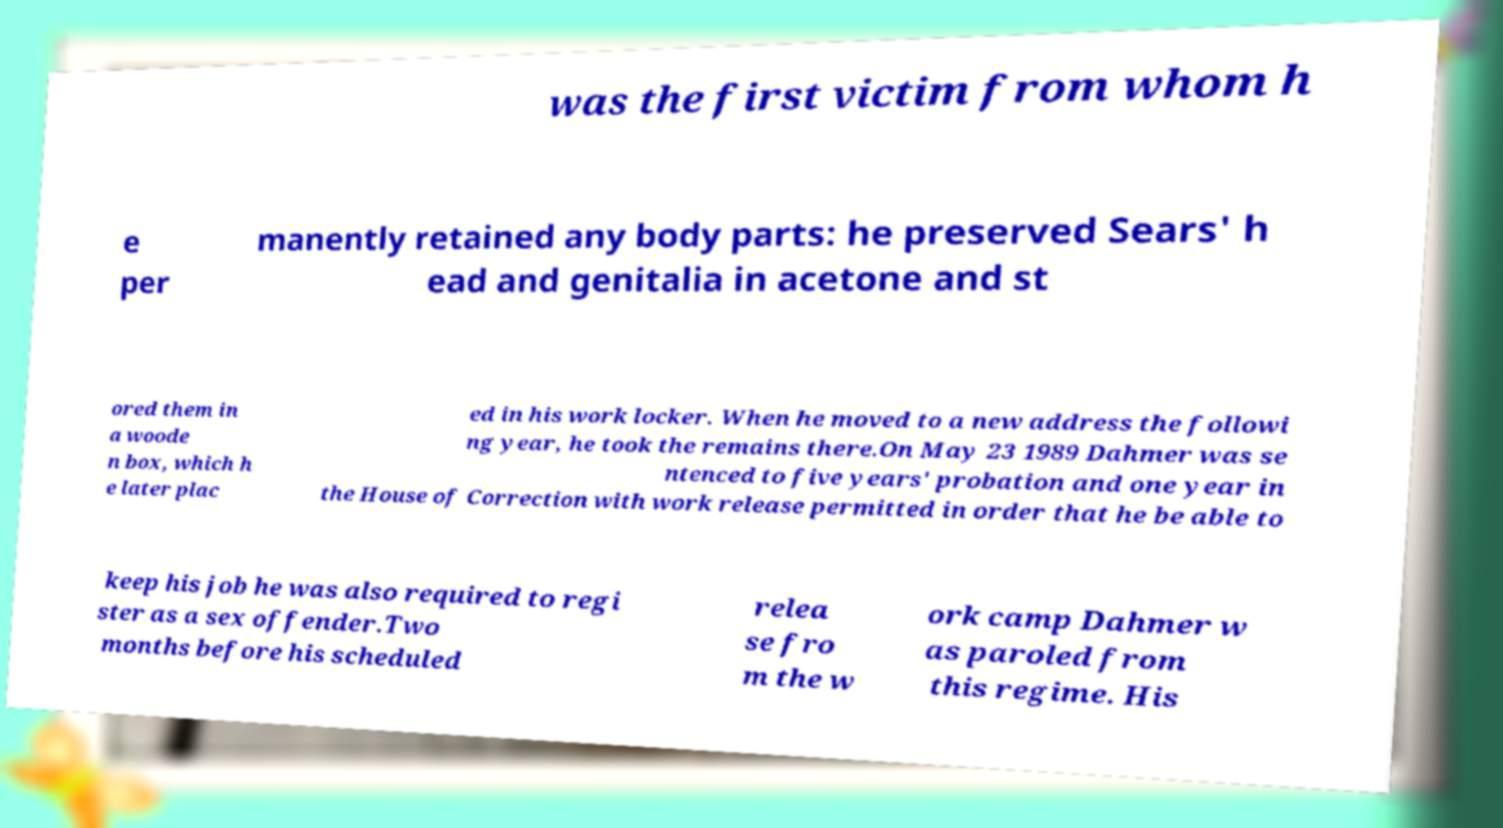There's text embedded in this image that I need extracted. Can you transcribe it verbatim? was the first victim from whom h e per manently retained any body parts: he preserved Sears' h ead and genitalia in acetone and st ored them in a woode n box, which h e later plac ed in his work locker. When he moved to a new address the followi ng year, he took the remains there.On May 23 1989 Dahmer was se ntenced to five years' probation and one year in the House of Correction with work release permitted in order that he be able to keep his job he was also required to regi ster as a sex offender.Two months before his scheduled relea se fro m the w ork camp Dahmer w as paroled from this regime. His 